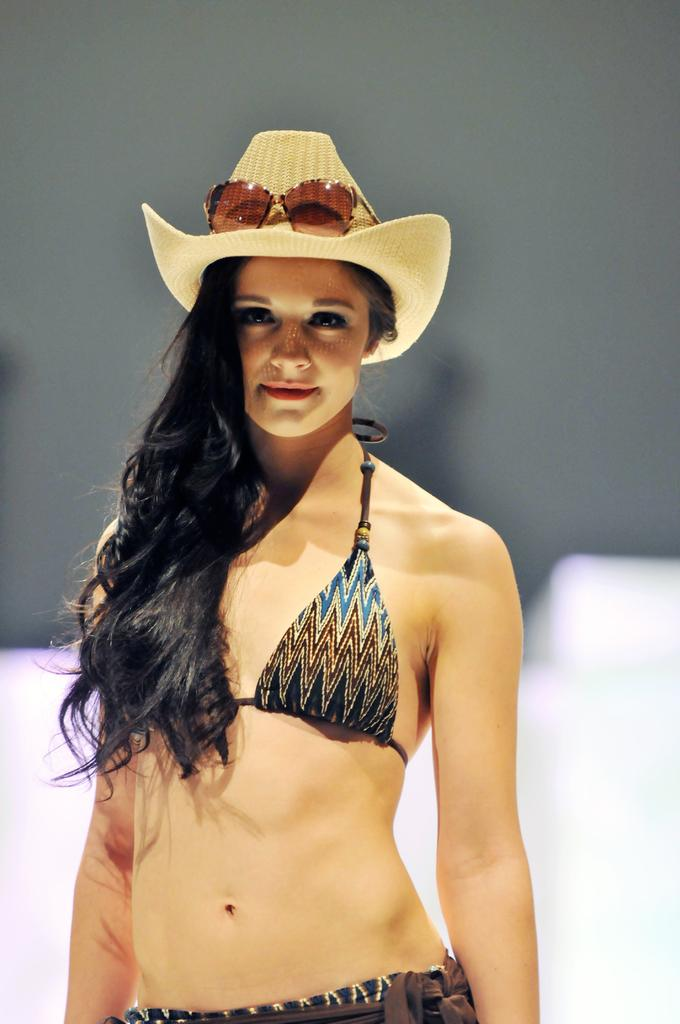Who is present in the image? There is a woman in the image. What is the woman wearing on her head? The woman is wearing a hat and goggles on her head. Can you describe the background of the image? The background of the image is blurry. What type of animals can be heard making noises in the background of the image? There are no animals or sounds present in the image, so it is not possible to determine what animals might be making noises. 